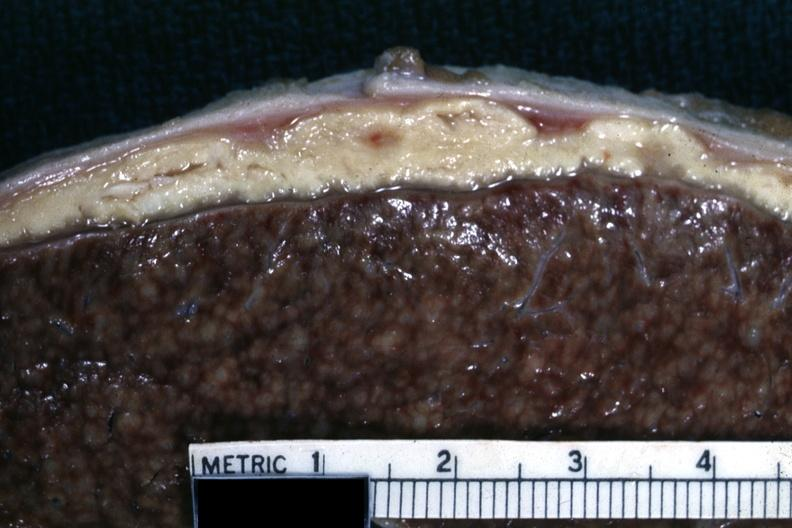what is cold abscess material very typical?
Answer the question using a single word or phrase. This 